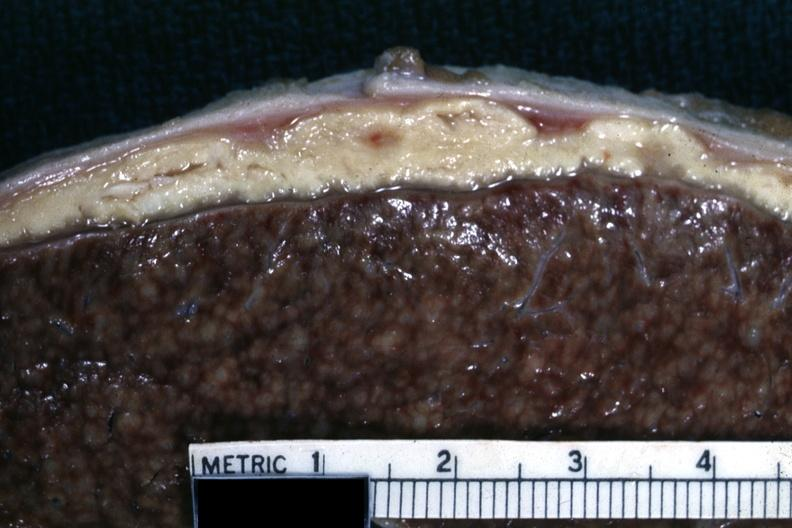what is cold abscess material very typical?
Answer the question using a single word or phrase. This 